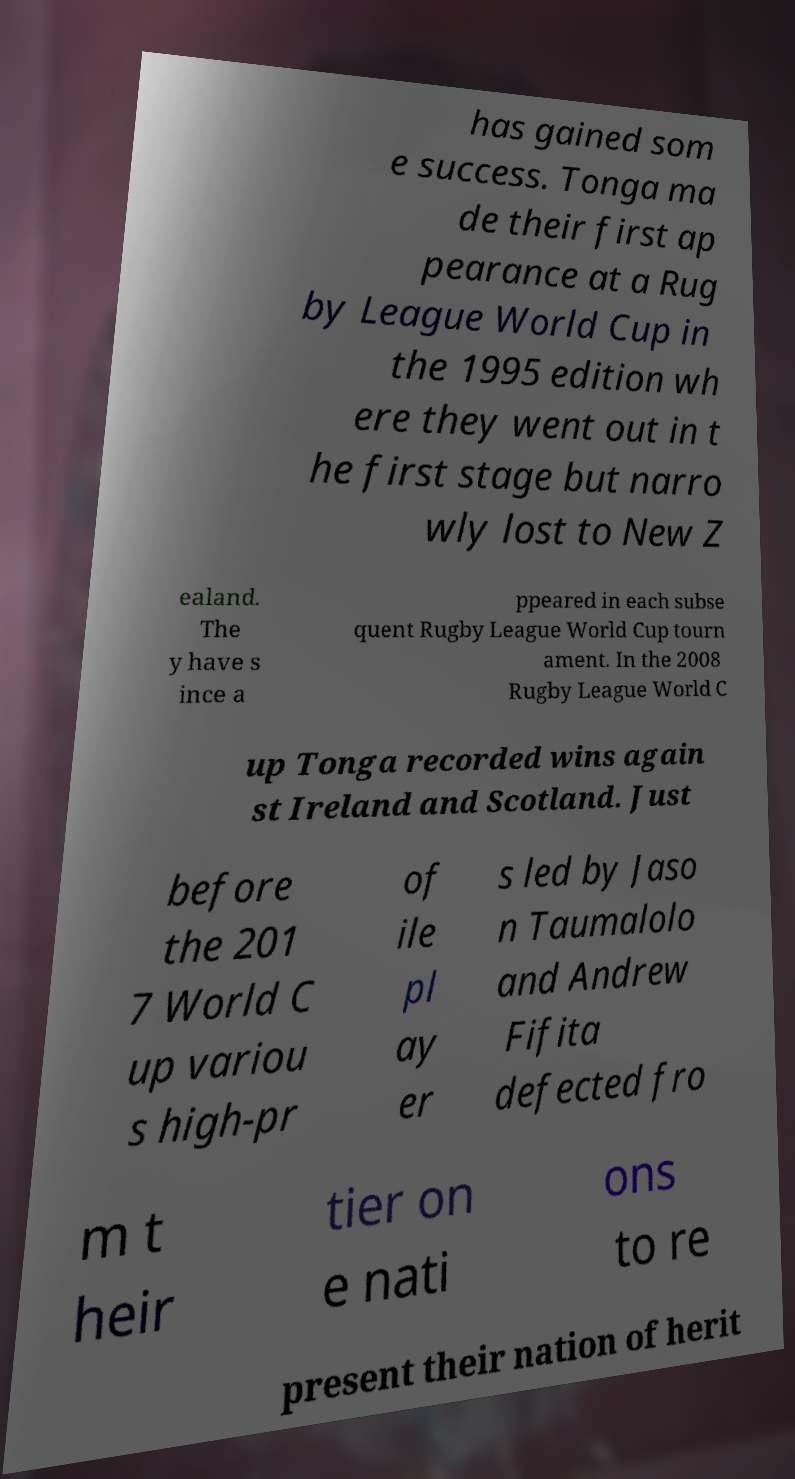Can you read and provide the text displayed in the image?This photo seems to have some interesting text. Can you extract and type it out for me? has gained som e success. Tonga ma de their first ap pearance at a Rug by League World Cup in the 1995 edition wh ere they went out in t he first stage but narro wly lost to New Z ealand. The y have s ince a ppeared in each subse quent Rugby League World Cup tourn ament. In the 2008 Rugby League World C up Tonga recorded wins again st Ireland and Scotland. Just before the 201 7 World C up variou s high-pr of ile pl ay er s led by Jaso n Taumalolo and Andrew Fifita defected fro m t heir tier on e nati ons to re present their nation of herit 